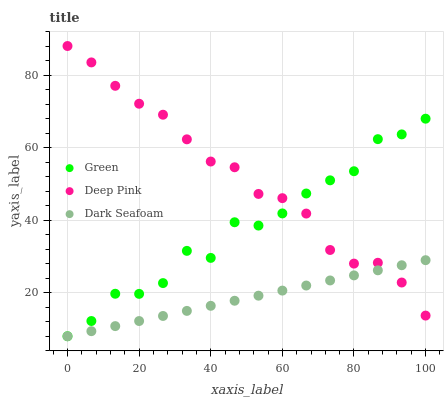Does Dark Seafoam have the minimum area under the curve?
Answer yes or no. Yes. Does Deep Pink have the maximum area under the curve?
Answer yes or no. Yes. Does Green have the minimum area under the curve?
Answer yes or no. No. Does Green have the maximum area under the curve?
Answer yes or no. No. Is Dark Seafoam the smoothest?
Answer yes or no. Yes. Is Green the roughest?
Answer yes or no. Yes. Is Deep Pink the smoothest?
Answer yes or no. No. Is Deep Pink the roughest?
Answer yes or no. No. Does Dark Seafoam have the lowest value?
Answer yes or no. Yes. Does Deep Pink have the lowest value?
Answer yes or no. No. Does Deep Pink have the highest value?
Answer yes or no. Yes. Does Green have the highest value?
Answer yes or no. No. Does Green intersect Deep Pink?
Answer yes or no. Yes. Is Green less than Deep Pink?
Answer yes or no. No. Is Green greater than Deep Pink?
Answer yes or no. No. 